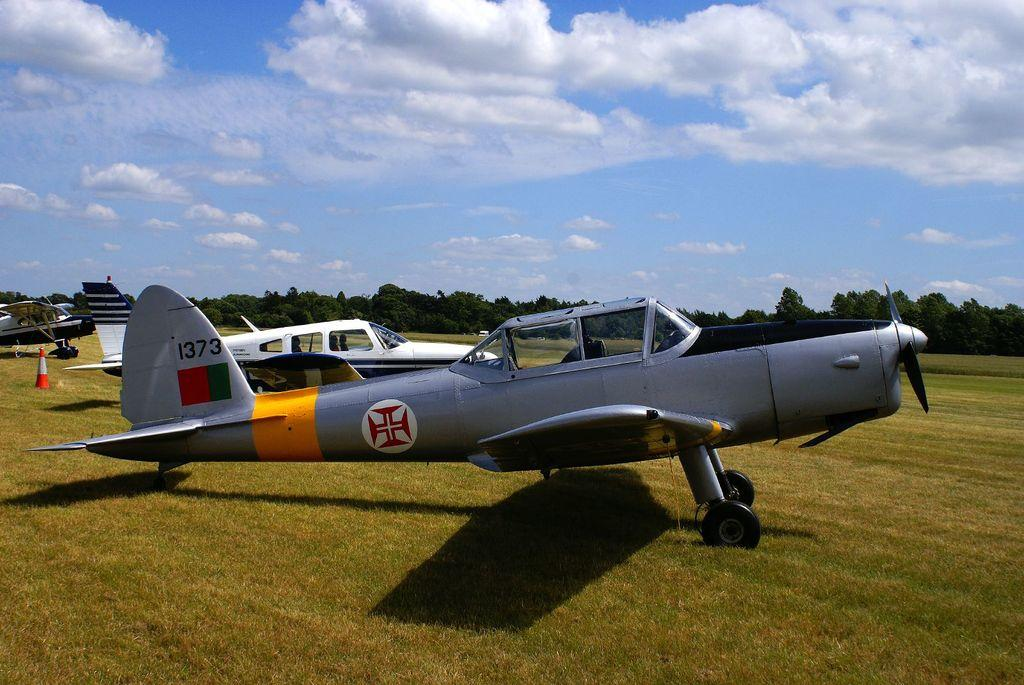Provide a one-sentence caption for the provided image. Grey propeller war plane with a German cross insignia plus the unit number 1373 on the body. 